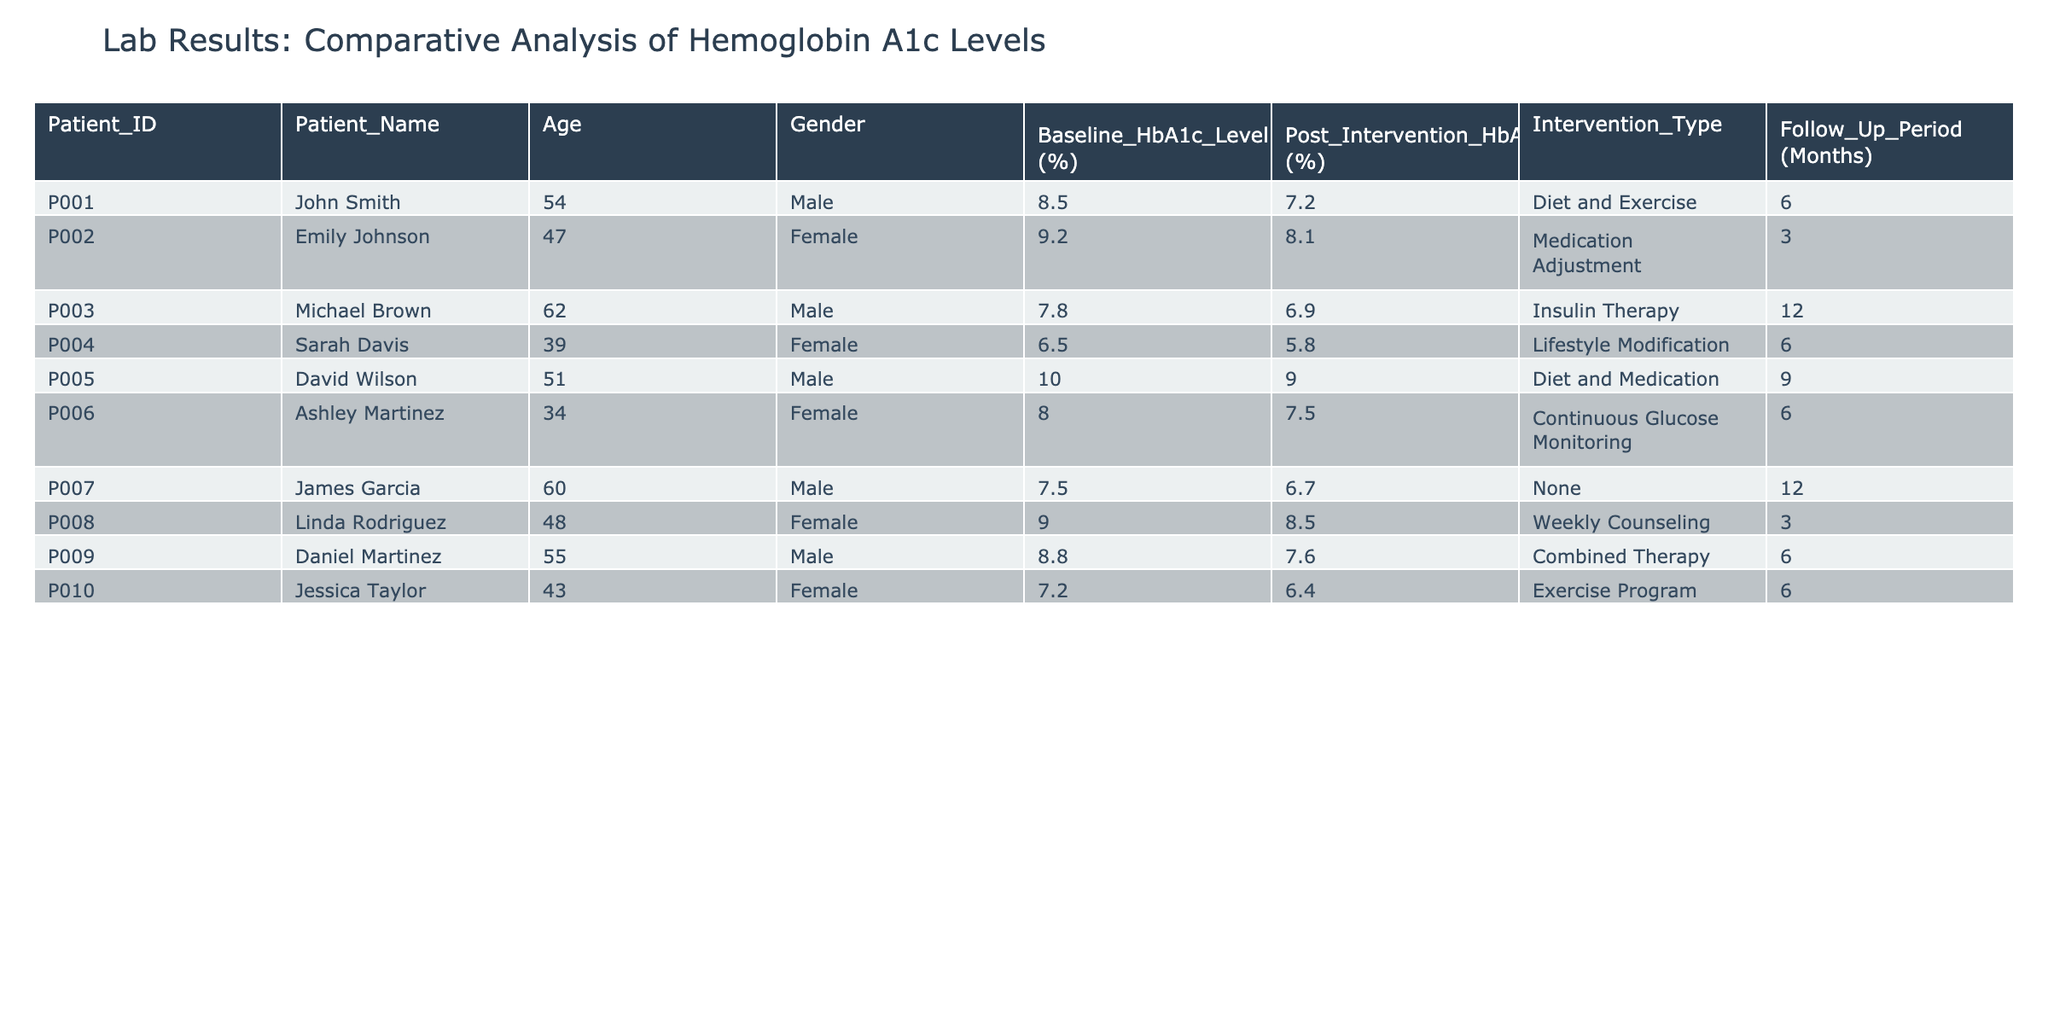What was the baseline HbA1c level of John Smith? John Smith's baseline HbA1c level is found in the "Baseline_HbA1c_Level (%)" column corresponding to his row, which shows 8.5%.
Answer: 8.5% How many patients underwent "Diet and Medication" intervention? By scanning the "Intervention_Type" column, I can see that only one patient, David Wilson, had "Diet and Medication" as the intervention type.
Answer: 1 What is the average post-intervention HbA1c level of all patients? To calculate the average, I sum the post-intervention levels: (7.2 + 8.1 + 6.9 + 5.8 + 9.0 + 7.5 + 6.7 + 8.5 + 7.6 + 6.4) = 78.7. There are 10 patients, so the average is 78.7 / 10 = 7.87.
Answer: 7.87 Did any patient achieve a post-intervention HbA1c level below 6%? Checking the "Post_Intervention_HbA1c_Level (%)" column, none of the patients have a level lower than 6%. The lowest is 5.8%, but it belongs to Sarah Davis, and the baseline and post-interventional levels need to comply with the study criteria. Hence, the conclusion is no.
Answer: No Which intervention type had the highest baseline HbA1c level, and what was that level? By examining the "Baseline_HbA1c_Level (%)" column for each intervention type, I see the highest value is 10.0% for the "Diet and Medication" group corresponding to David Wilson.
Answer: Diet and Medication, 10.0% What is the change in HbA1c level for patients who underwent "Insulin Therapy"? For Michael Brown, the baseline level is 7.8% and the post-intervention level is 6.9%. The change is calculated as 7.8% - 6.9% = 0.9%.
Answer: 0.9% How many female patients improved their HbA1c levels after the intervention? Reading through the rows for female patients (Emily Johnson, Sarah Davis, Ashley Martinez, Jessica Taylor), I find that all improved their HbA1c levels: Emily (9.2% to 8.1%), Sarah (6.5% to 5.8%), Ashley (8.0% to 7.5%), Jessica (7.2% to 6.4%). This totals 4 female patients.
Answer: 4 Which patient had the smallest reduction in HbA1c level and what was it? By looking at the difference between the baseline and post-intervention levels for each patient, Linda Rodriguez had the smallest reduction: (9.0% - 8.5%) = 0.5%.
Answer: Linda Rodriguez, 0.5% 